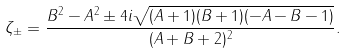<formula> <loc_0><loc_0><loc_500><loc_500>\zeta _ { \pm } = \frac { B ^ { 2 } - A ^ { 2 } \pm 4 i \sqrt { ( A + 1 ) ( B + 1 ) ( - A - B - 1 ) } } { ( A + B + 2 ) ^ { 2 } } .</formula> 